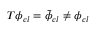<formula> <loc_0><loc_0><loc_500><loc_500>T \phi _ { c l } = \bar { \phi } _ { c l } \neq \phi _ { c l }</formula> 